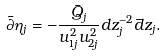Convert formula to latex. <formula><loc_0><loc_0><loc_500><loc_500>\bar { \partial } \eta _ { j } = - \frac { \bar { Q } _ { j } } { u _ { 1 j } ^ { 2 } u _ { 2 j } ^ { 2 } } d z _ { j } ^ { - 2 } \bar { d } z _ { j } .</formula> 